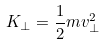Convert formula to latex. <formula><loc_0><loc_0><loc_500><loc_500>K _ { \perp } = \frac { 1 } { 2 } m v _ { \perp } ^ { 2 }</formula> 